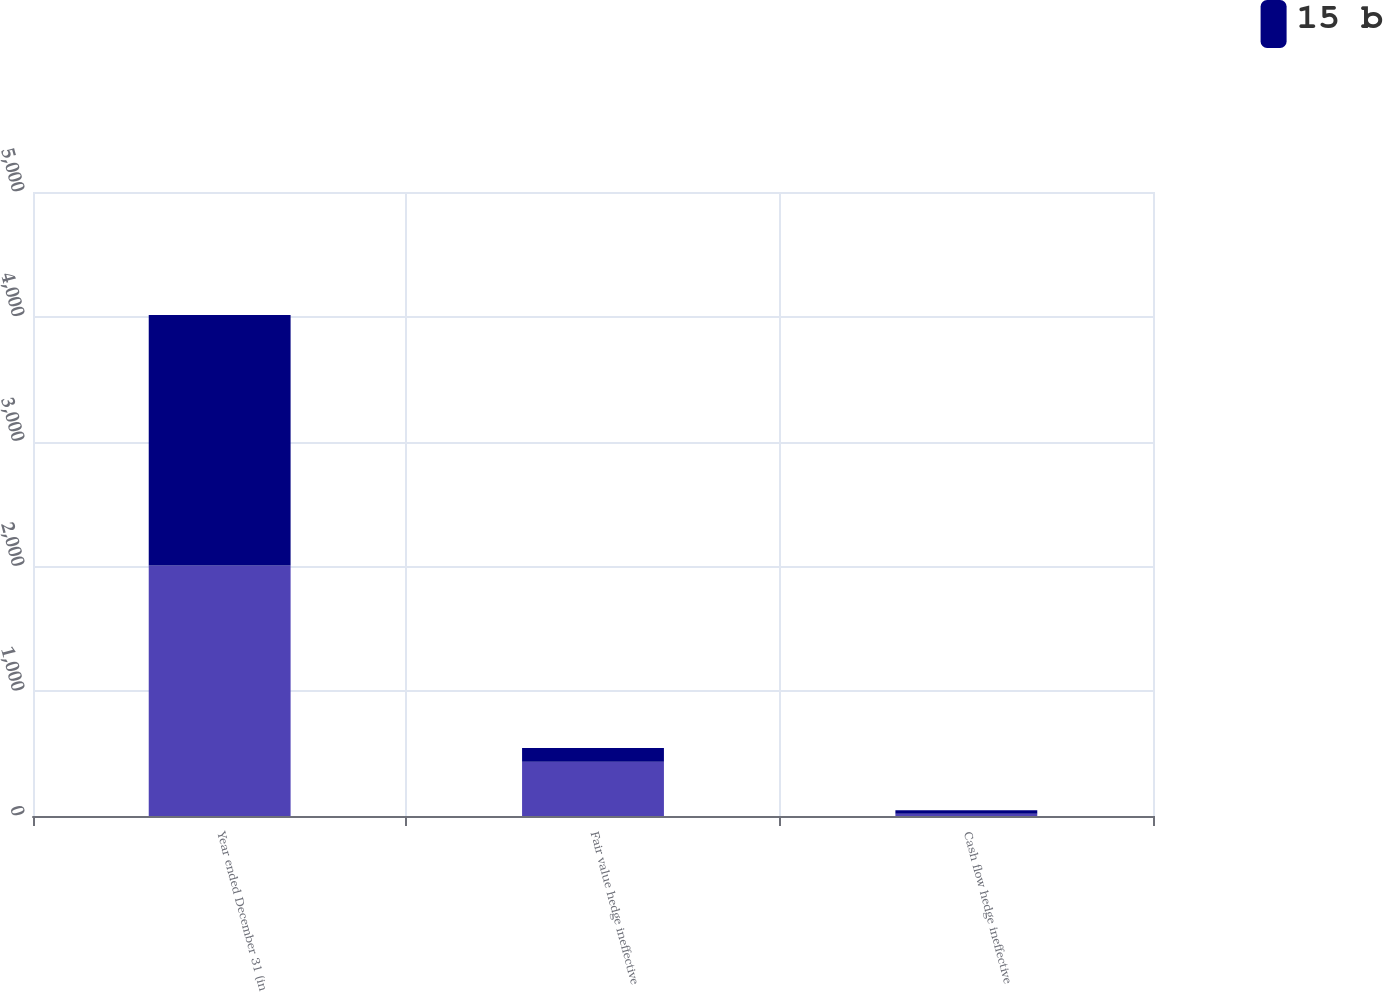Convert chart to OTSL. <chart><loc_0><loc_0><loc_500><loc_500><stacked_bar_chart><ecel><fcel>Year ended December 31 (in<fcel>Fair value hedge ineffective<fcel>Cash flow hedge ineffective<nl><fcel>nan<fcel>2008<fcel>434<fcel>18<nl><fcel>15 b<fcel>2007<fcel>111<fcel>29<nl></chart> 